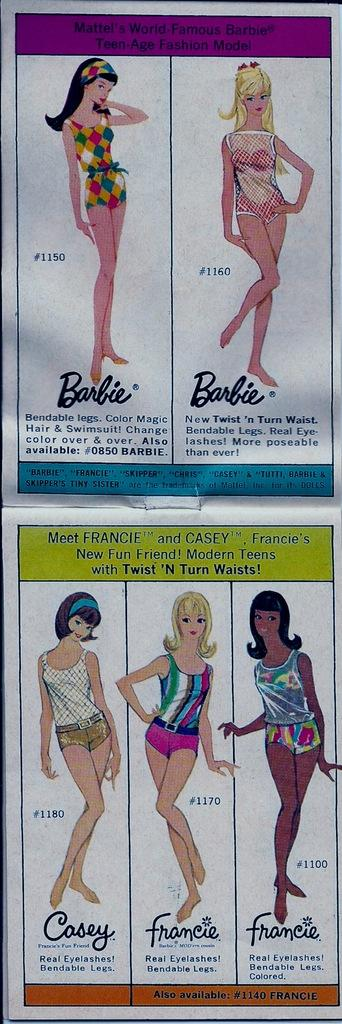Who is present in the image? There are women in the image. What are the women wearing? The women are wearing different color dresses. What can be seen above and below the image? There is text written above and below the image. What type of punishment is being depicted in the image? There is no punishment being depicted in the image; it features women wearing different color dresses. What role does the roof play in the image? There is no roof present in the image; it is not relevant to the scene depicted. 